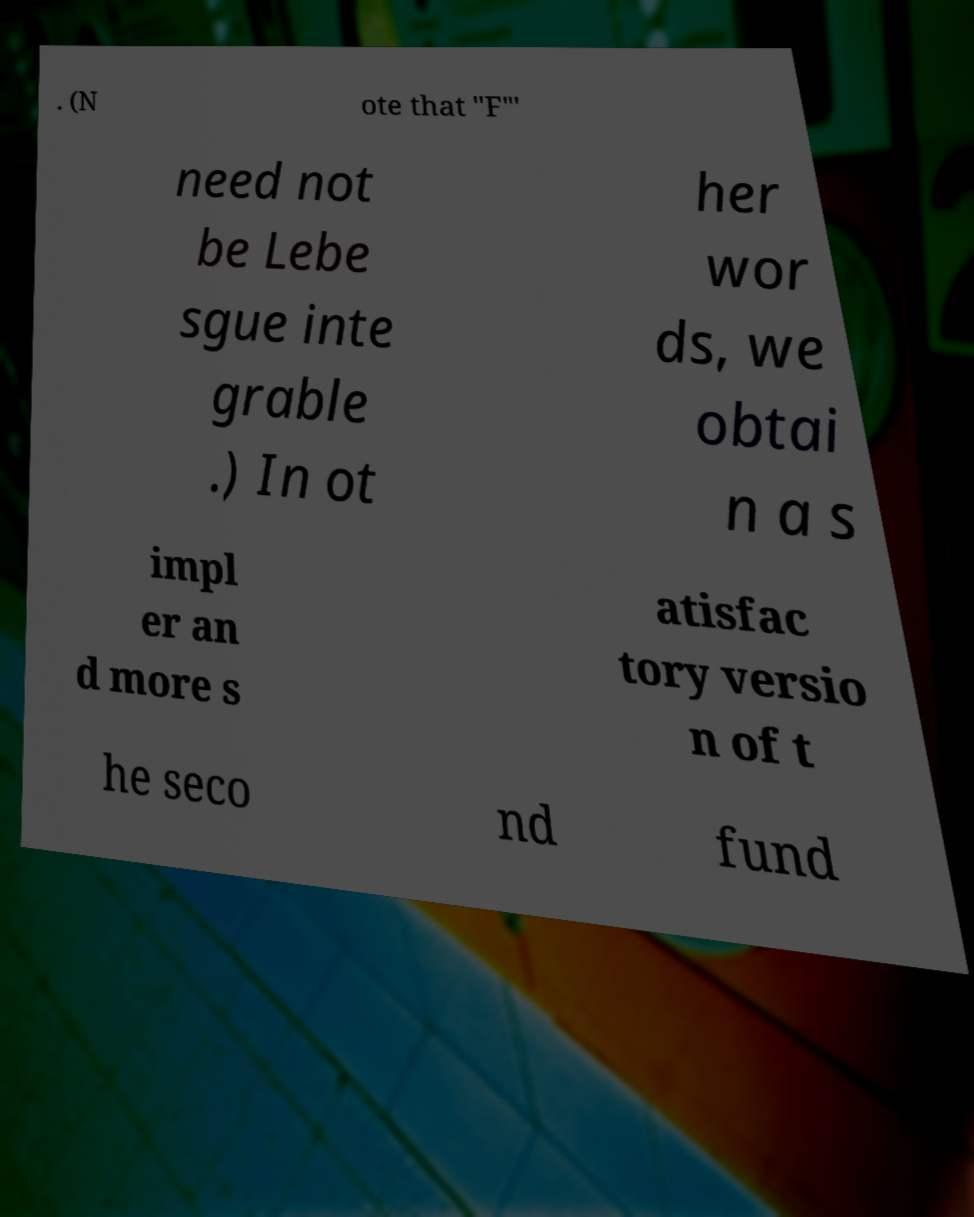Please identify and transcribe the text found in this image. . (N ote that "F"′ need not be Lebe sgue inte grable .) In ot her wor ds, we obtai n a s impl er an d more s atisfac tory versio n of t he seco nd fund 